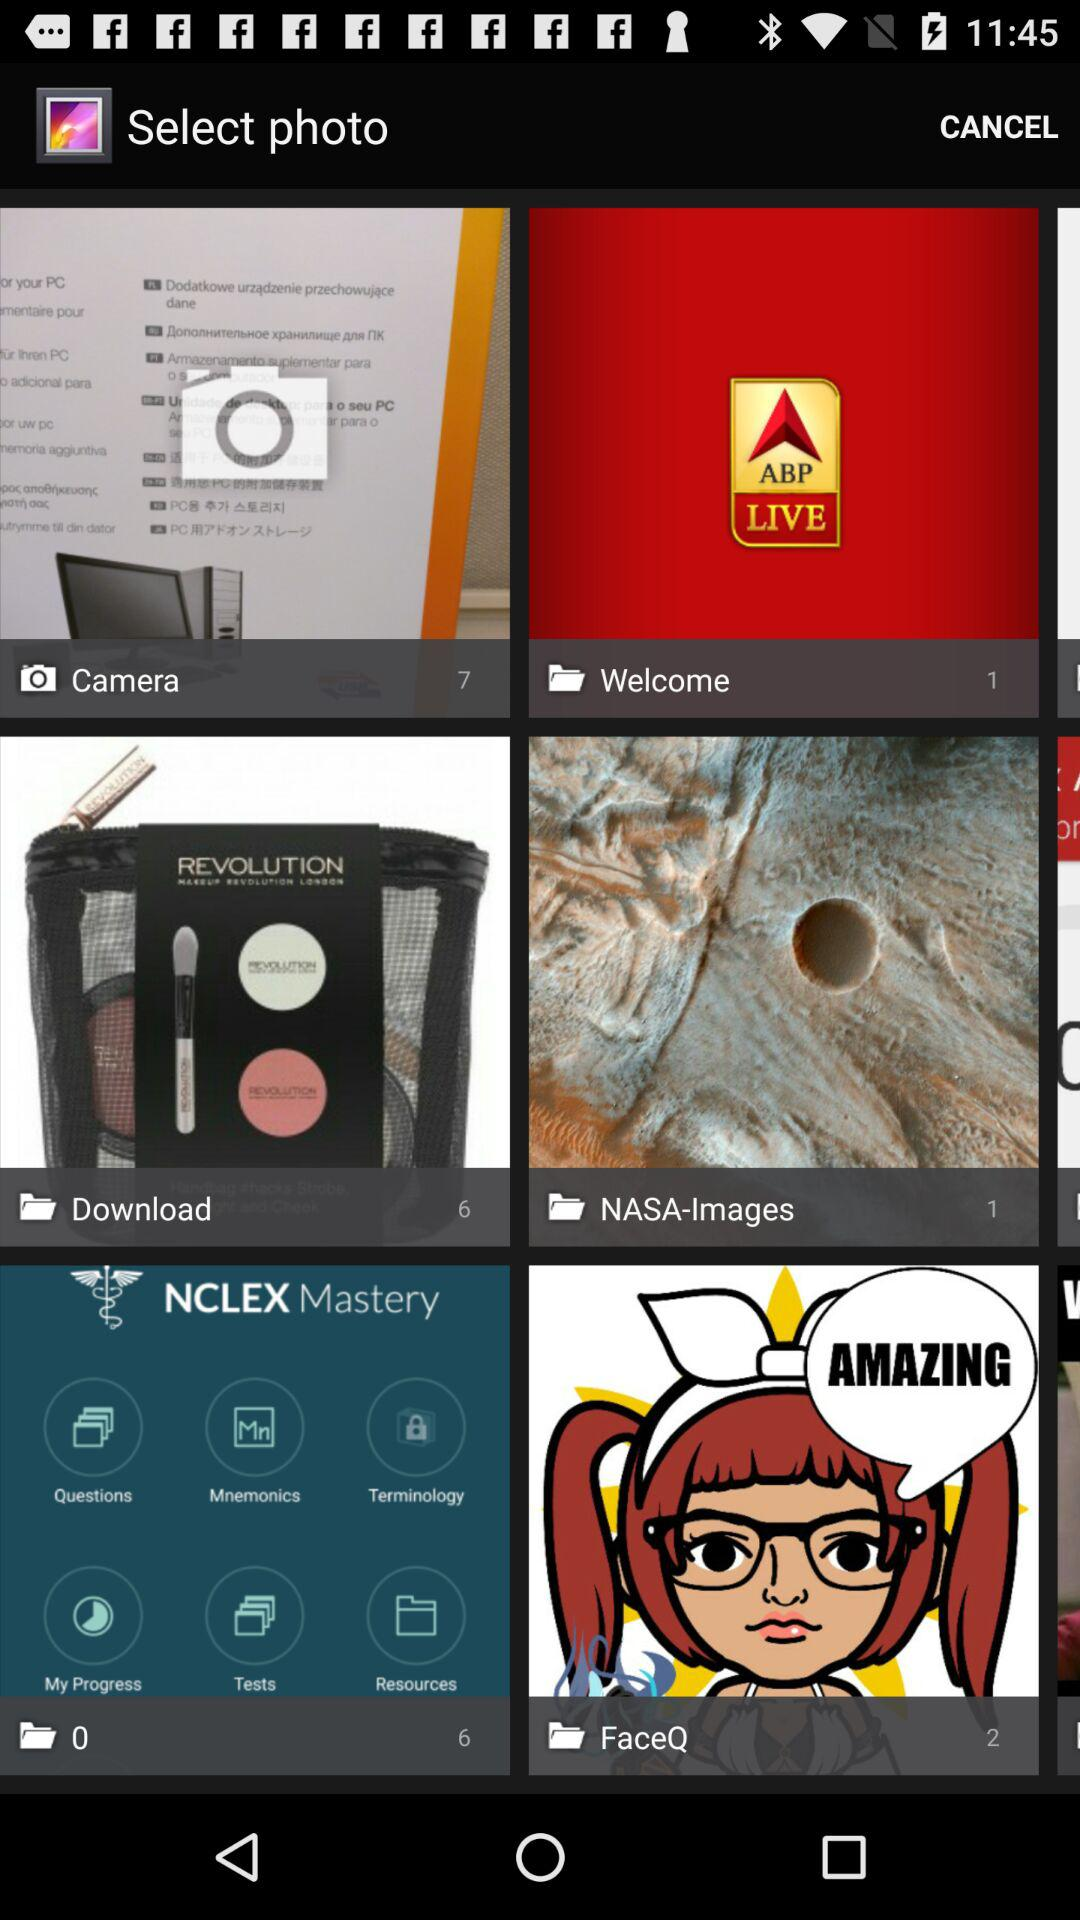How many photos are there in the camera folder? There are 7 photos in the camera folder. 